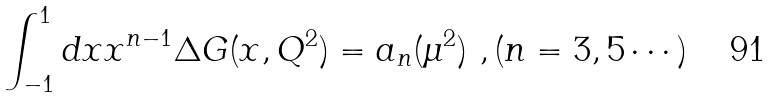<formula> <loc_0><loc_0><loc_500><loc_500>\int ^ { 1 } _ { - 1 } d x x ^ { n - 1 } \Delta G ( x , Q ^ { 2 } ) = a _ { n } ( \mu ^ { 2 } ) \ , ( n = 3 , 5 \cdots )</formula> 